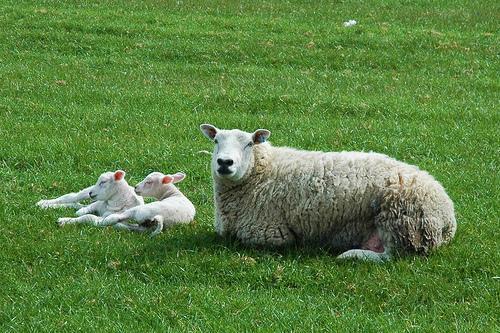How many animals?
Give a very brief answer. 3. How many babies?
Give a very brief answer. 2. 